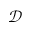Convert formula to latex. <formula><loc_0><loc_0><loc_500><loc_500>\mathcal { D }</formula> 